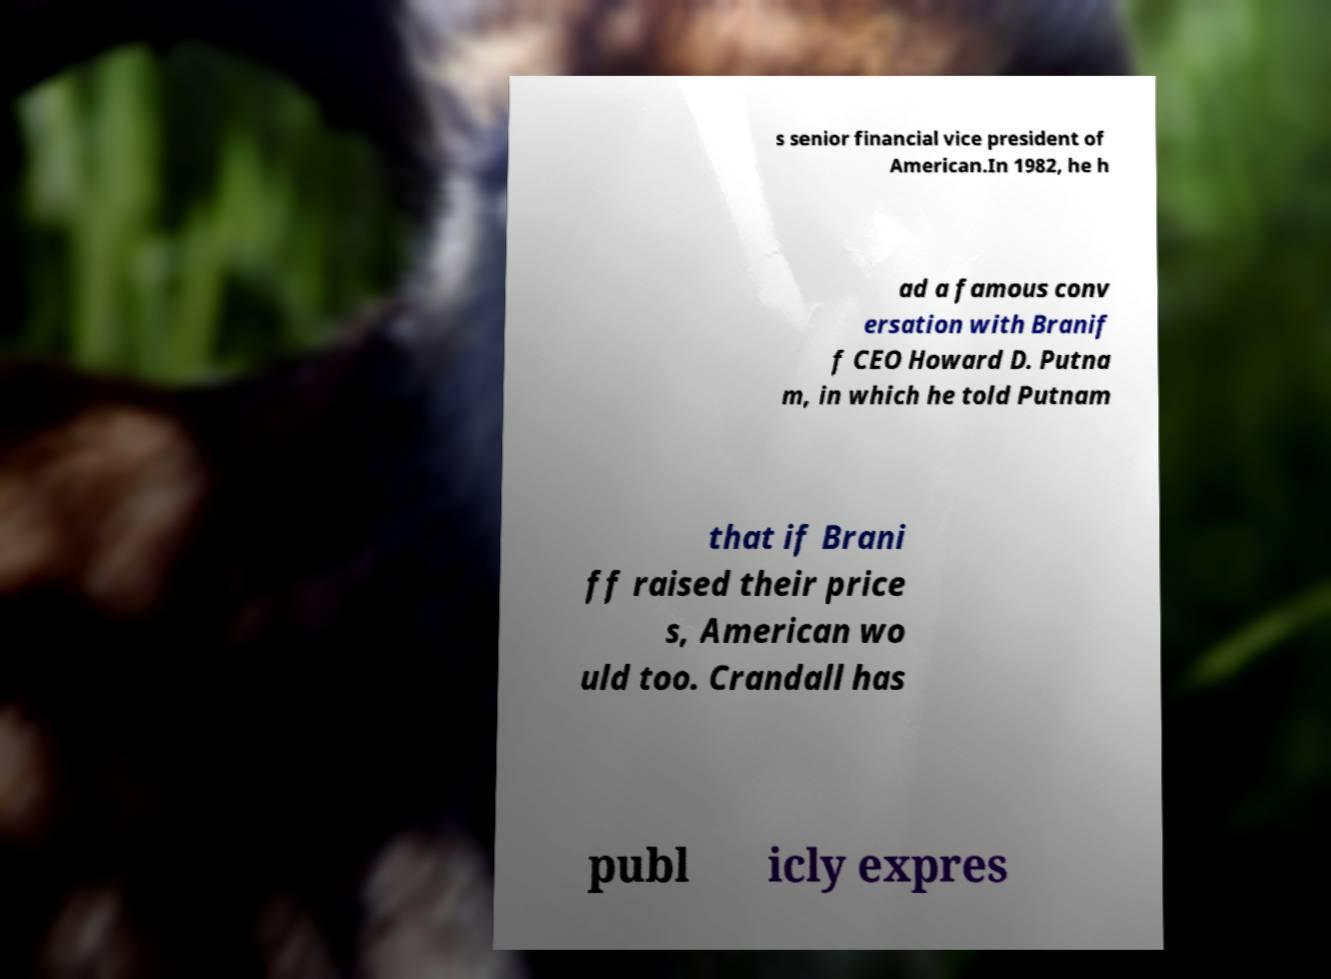Can you accurately transcribe the text from the provided image for me? s senior financial vice president of American.In 1982, he h ad a famous conv ersation with Branif f CEO Howard D. Putna m, in which he told Putnam that if Brani ff raised their price s, American wo uld too. Crandall has publ icly expres 